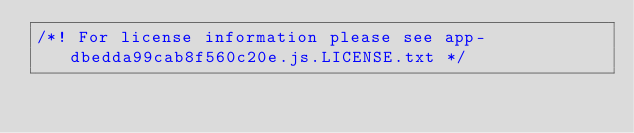<code> <loc_0><loc_0><loc_500><loc_500><_JavaScript_>/*! For license information please see app-dbedda99cab8f560c20e.js.LICENSE.txt */</code> 